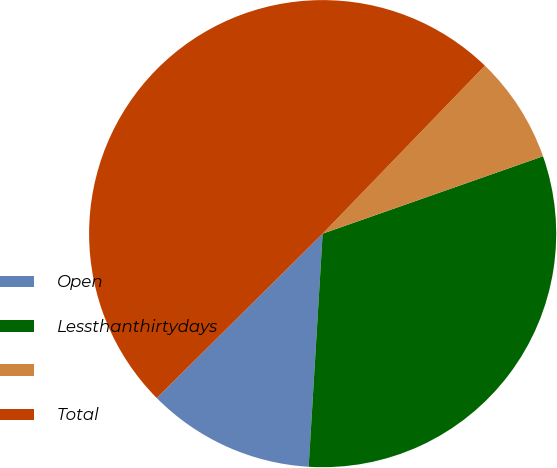<chart> <loc_0><loc_0><loc_500><loc_500><pie_chart><fcel>Open<fcel>Lessthanthirtydays<fcel>Unnamed: 2<fcel>Total<nl><fcel>11.62%<fcel>31.33%<fcel>7.4%<fcel>49.65%<nl></chart> 